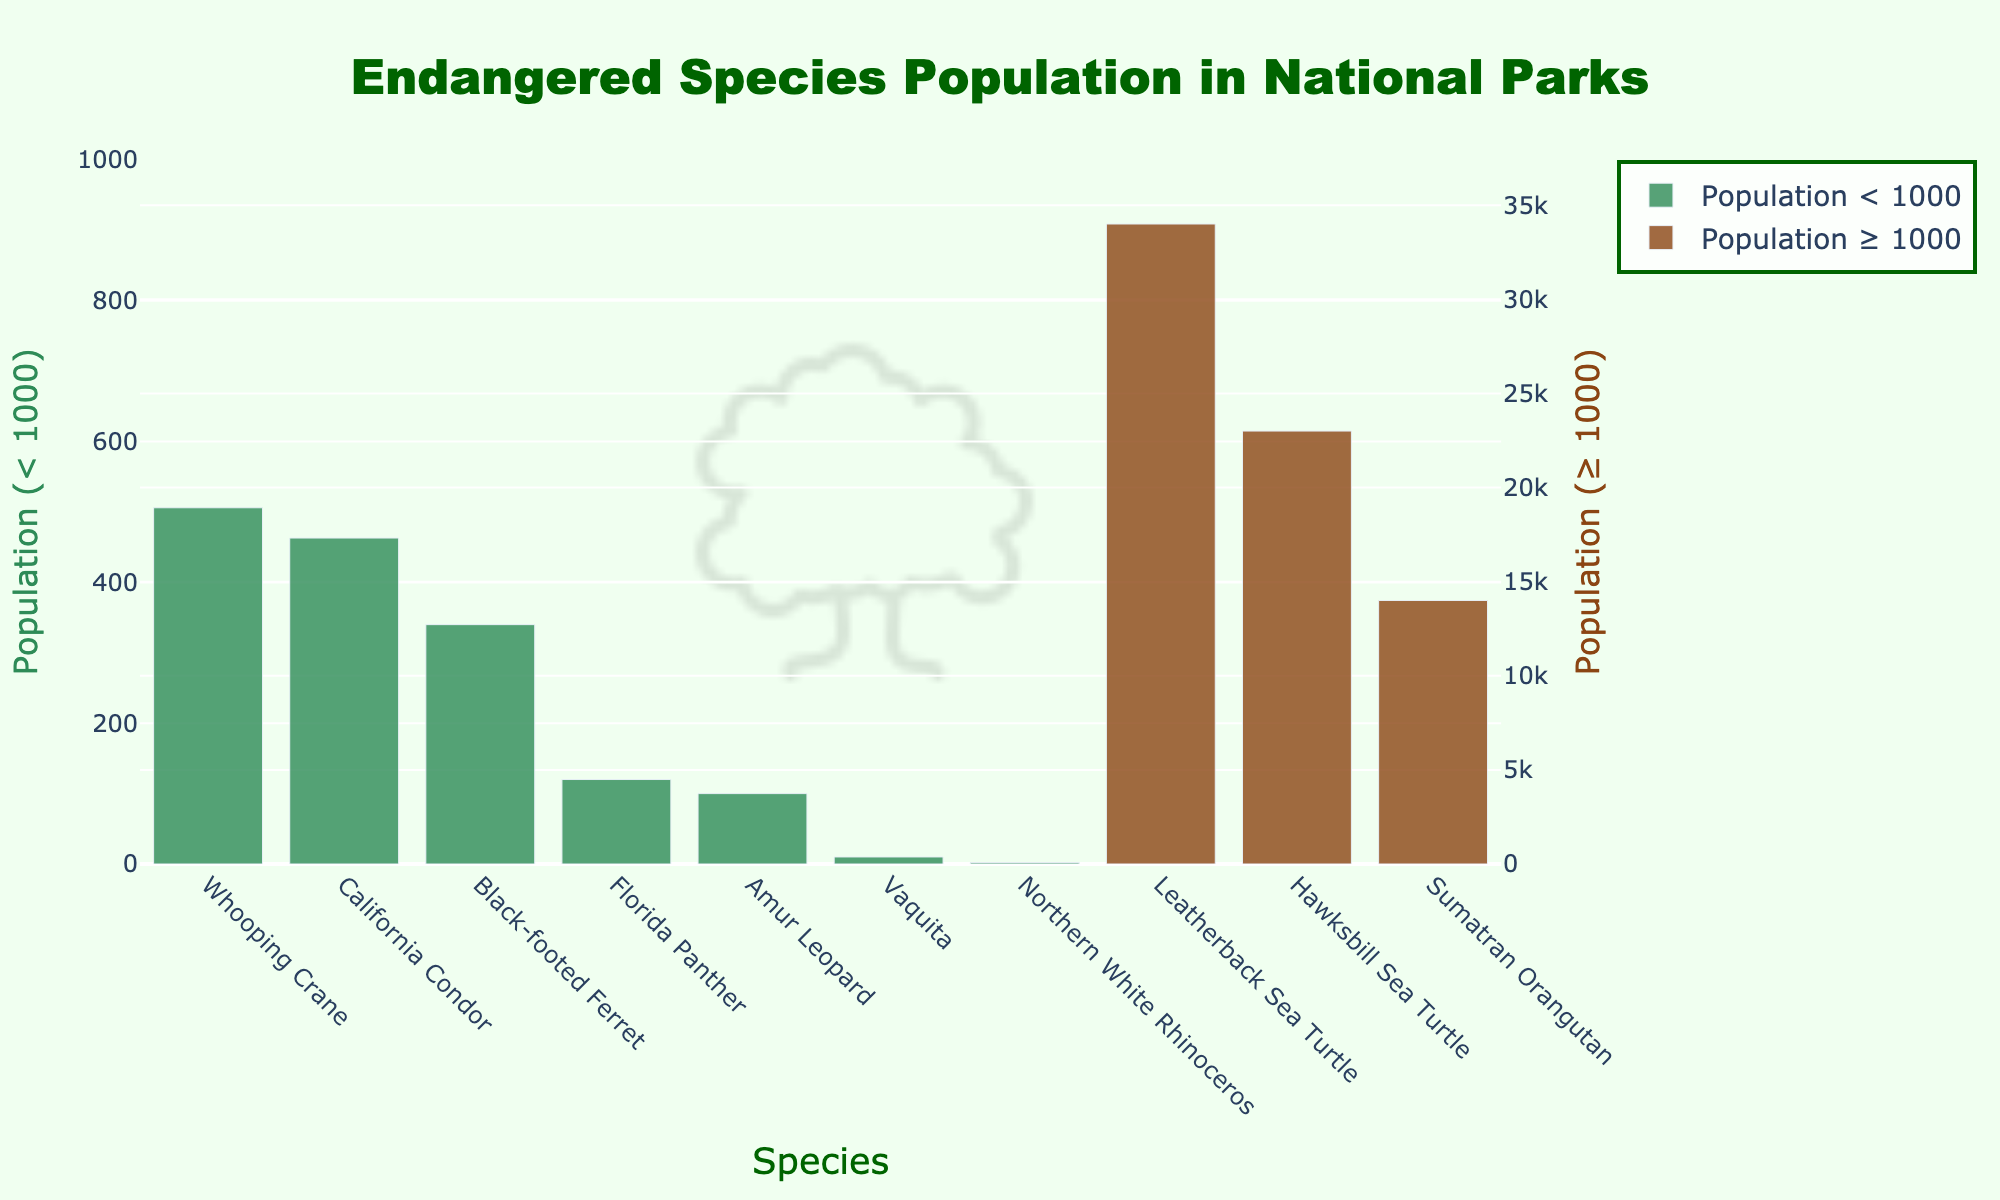What species has the highest population? By identifying the tallest bar, we see the Leatherback Sea Turtle has the highest population with 34,000 individuals
Answer: Leatherback Sea Turtle Which species has the lowest population? The smallest bar corresponds to the Northern White Rhinoceros with a population of only 2 individuals
Answer: Northern White Rhinoceros How many more California Condors are there compared to Black-footed Ferrets? The population of California Condors is 463, and Black-footed Ferrets is 340. The difference is 463 - 340 = 123
Answer: 123 What is the median population of the Top 5 species? The top 5 species based on population in descending order are Leatherback Sea Turtle (34,000), Hawksbill Sea Turtle (23,000), Sumatran Orangutan (14,000), Whooping Crane (506), and California Condor (463). The median value is the middle one, which is Sumatran Orangutan with a population of 14,000
Answer: 14,000 Compare the population of the Florida Panther and the Amur Leopard. Which is greater? Florida Panther has a population of 120, while Amur Leopard has a population of 100. Therefore, the Florida Panther population is greater
Answer: Florida Panther What is the total population of all species with populations less than 1,000? Summing the populations of species with less than 1,000: California Condor (463), Florida Panther (120), Black-footed Ferret (340), Whooping Crane (506), Amur Leopard (100), Northern White Rhinoceros (2), Vaquita (10). Total = 463 + 120 + 340 + 506 + 100 + 2 + 10 = 1,541
Answer: 1,541 Which species are represented by green bars? Referring to the visual attribute, green bars represent species with populations less than 1,000: California Condor, Florida Panther, Black-footed Ferret, Whooping Crane, Amur Leopard, Northern White Rhinoceros, and Vaquita
Answer: California Condor, Florida Panther, Black-footed Ferret, Whooping Crane, Amur Leopard, Northern White Rhinoceros, Vaquita What percentage of the total population do the Leatherback Sea Turtle and Hawksbill Sea Turtle together represent? Summing the populations of Leatherback Sea Turtle (34,000) and Hawksbill Sea Turtle (23,000), we get 57,000. The total population for all listed species is 87,541. Percentage = (57,000 / 87,541) * 100 = 65.12%
Answer: 65.12% 